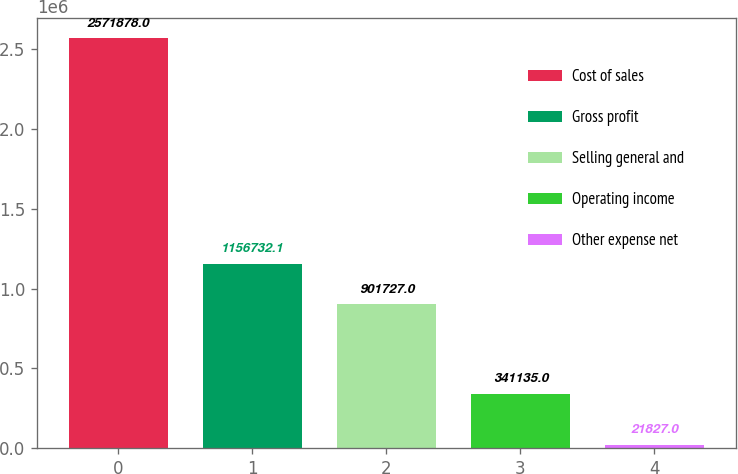<chart> <loc_0><loc_0><loc_500><loc_500><bar_chart><fcel>Cost of sales<fcel>Gross profit<fcel>Selling general and<fcel>Operating income<fcel>Other expense net<nl><fcel>2.57188e+06<fcel>1.15673e+06<fcel>901727<fcel>341135<fcel>21827<nl></chart> 